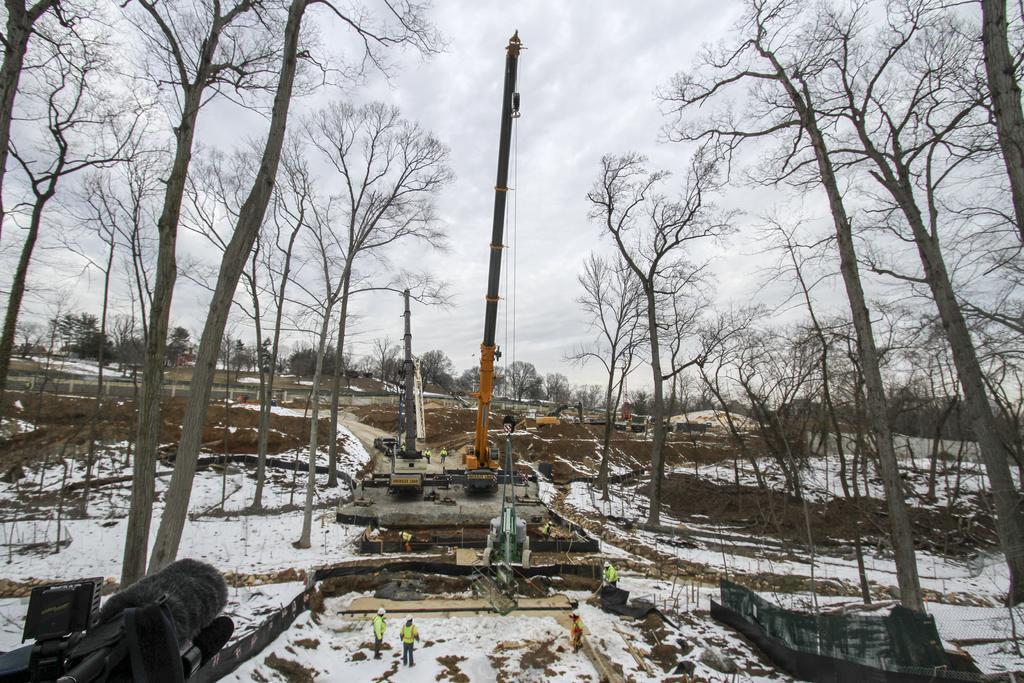Please provide a concise description of this image. In this picture we can see some vehicles, some people are working on the snow, around there are so many trees. 